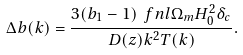<formula> <loc_0><loc_0><loc_500><loc_500>\Delta b ( k ) = \frac { 3 ( b _ { 1 } - 1 ) \ f n l \Omega _ { m } H _ { 0 } ^ { 2 } \delta _ { c } } { D ( z ) k ^ { 2 } T ( k ) } .</formula> 